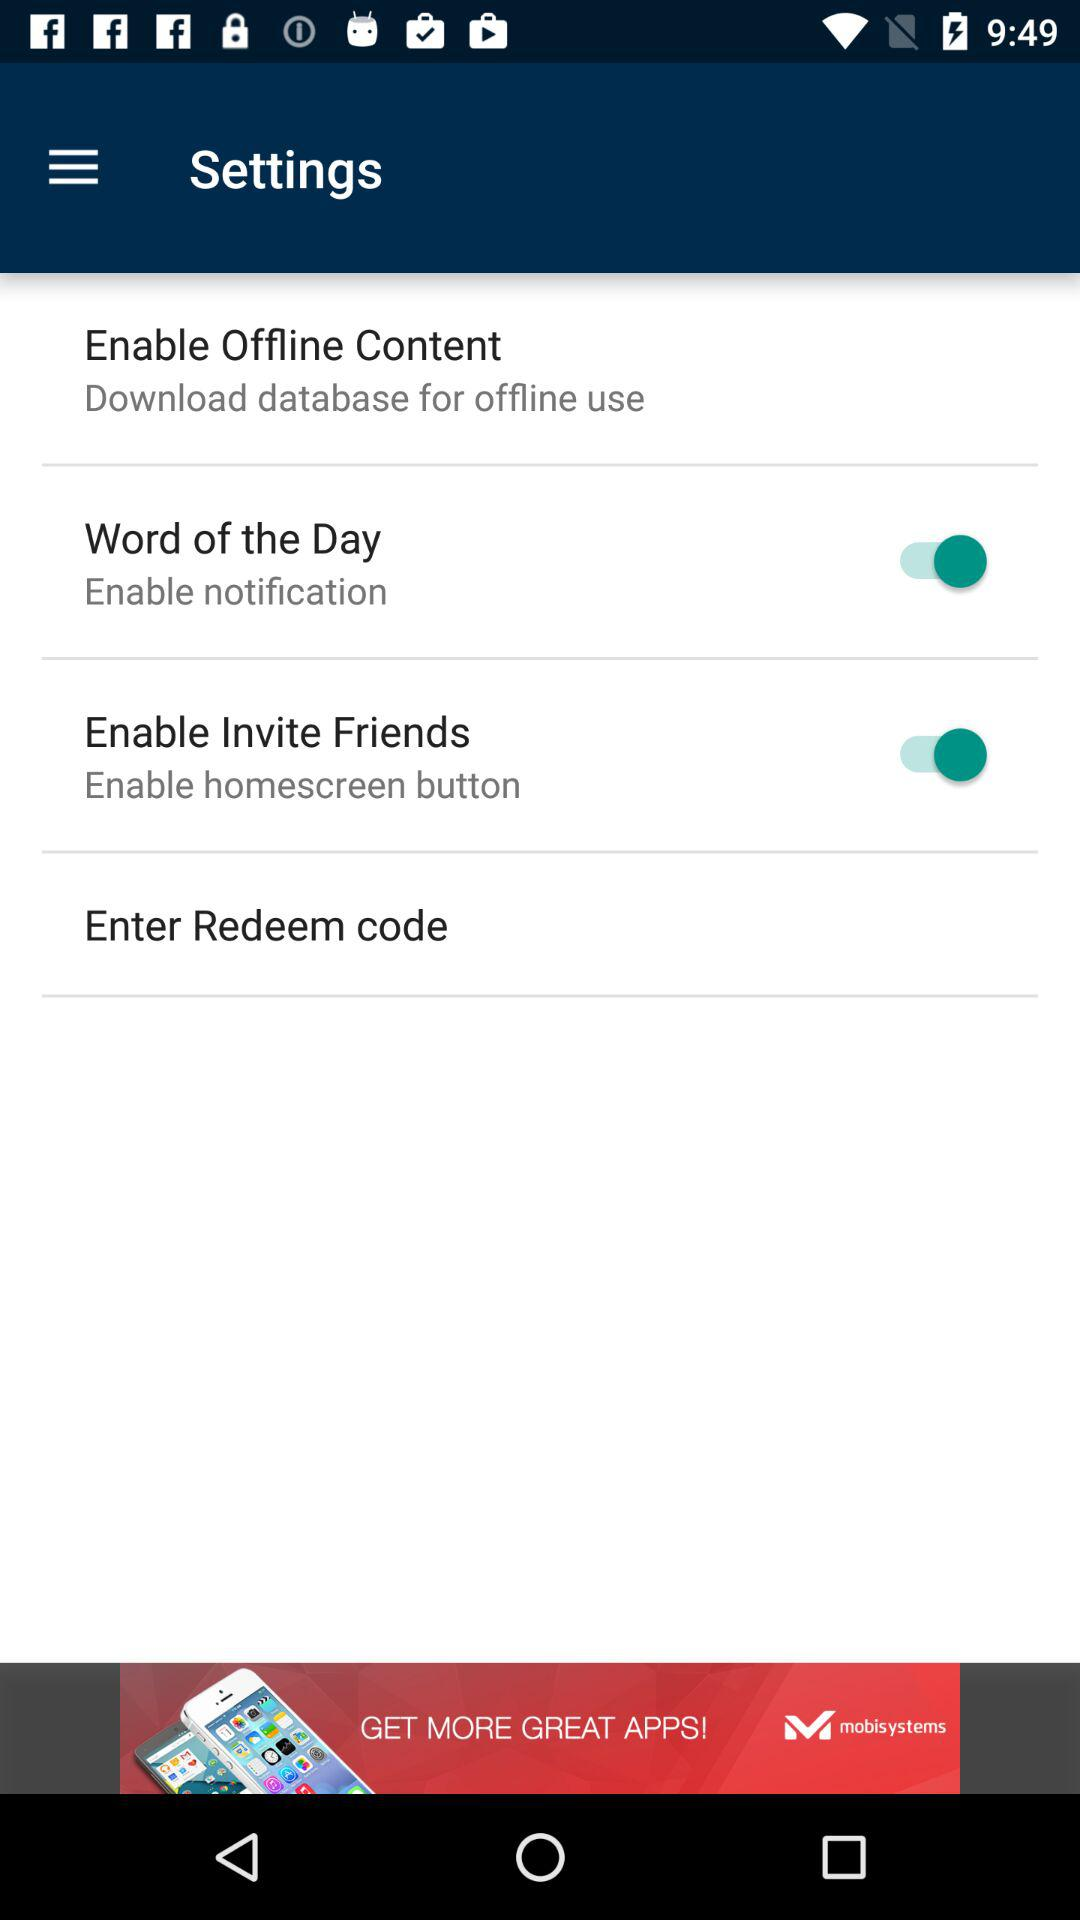What's the status of the "Word of the Day"? The status is "on". 